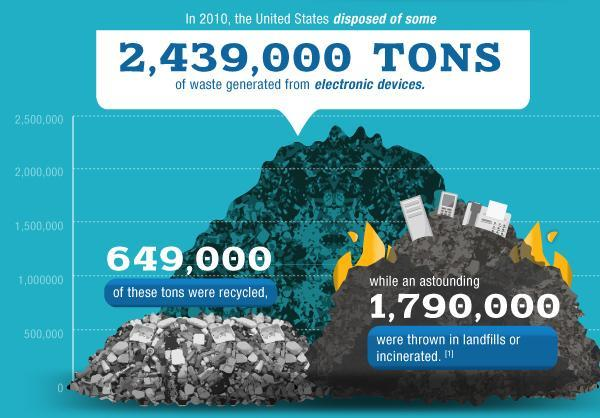How much electronic waste was thrown in landfills in tons?
Answer the question with a short phrase. 1,790,000 